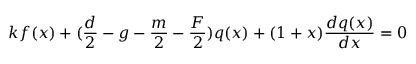Convert formula to latex. <formula><loc_0><loc_0><loc_500><loc_500>k f ( x ) + ( \frac { d } { 2 } - g - \frac { m } { 2 } - \frac { F } { 2 } ) q ( x ) + ( 1 + x ) \frac { d q ( x ) } { d x } = 0</formula> 